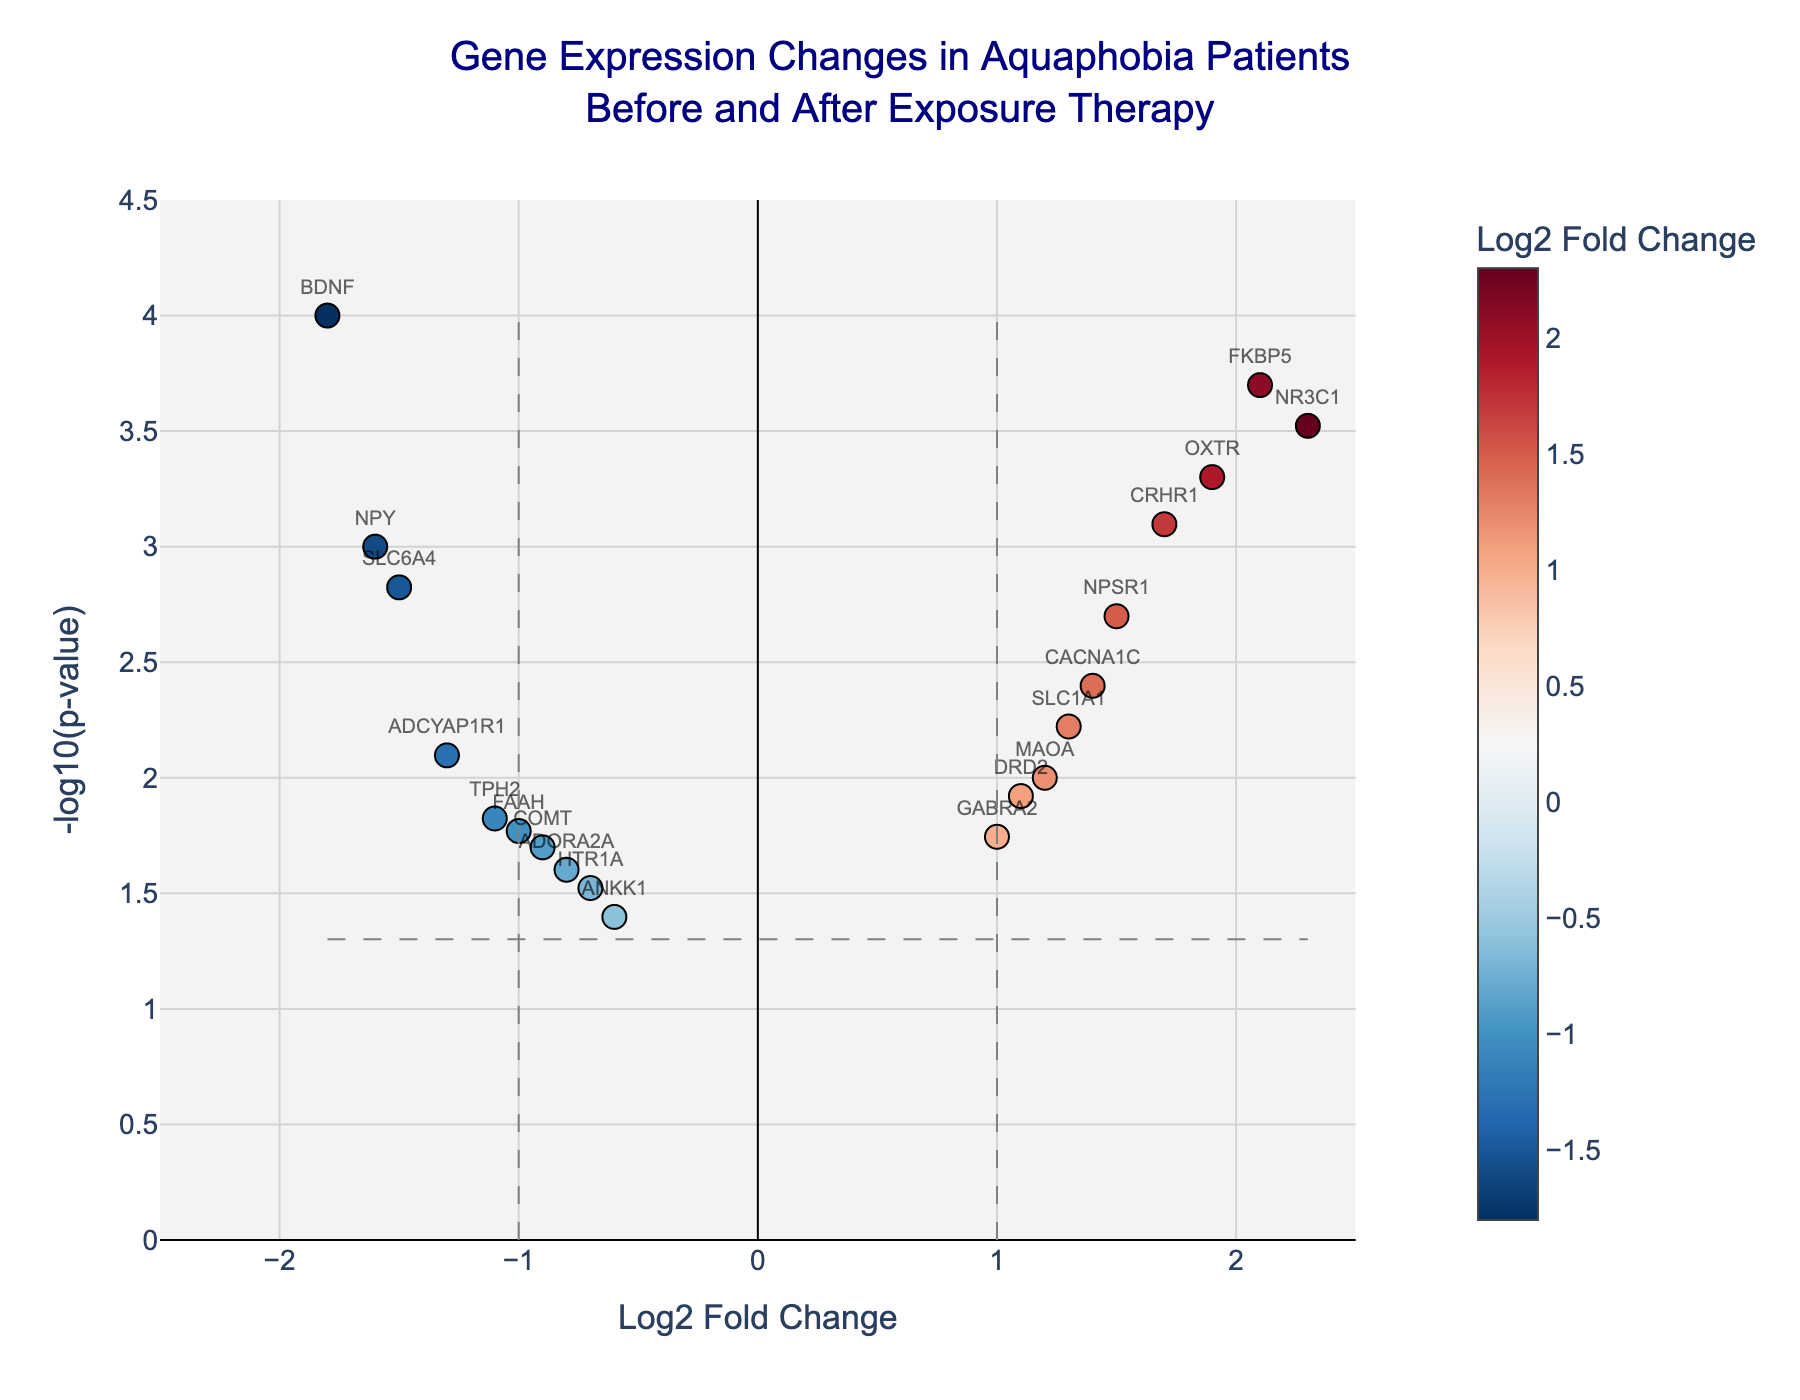What is the title of the figure? The title is usually located at the top of the figure and is used to summarize the content of the plot. The title in this plot is clearly displayed at the top center.
Answer: Gene Expression Changes in Aquaphobia Patients Before and After Exposure Therapy How many genes have a p-value less than 0.05? To determine this, you need to look at the horizontal line that marks the significance threshold of -log10(0.05). Any points above this line have a p-value less than 0.05. By counting these points, we find there are 15 points above the line.
Answer: 15 Which gene has the highest negative Log2 Fold Change? You need to look for the point located furthest to the left on the x-axis, which represents the most negative Log2 Fold Change. In this case, BDNF with a Log2 Fold Change of -1.8 is the furthest left.
Answer: BDNF Which gene shows the most significant change in expression? The most significant change in expression corresponds to the smallest p-value, which will have the highest -log10(p-value) in the plot. By scanning the plot, FKBP5 stands out as the gene with the highest -log10(p-value).
Answer: FKBP5 How many genes have a Log2 Fold Change greater than 1.0? To answer this, look to the right of the vertical line at Log2 Fold Change = 1.0 and count the points. The genes satisfying this condition are NR3C1, OXTR, FKBP5, CRHR1, NPSR1, CACNA1C, SLC1A1, and DRD2.
Answer: 8 Which gene with a Log2 Fold Change greater than 1.0 has a p-value closest to 0.001? First, identify genes with Log2 Fold Change greater than 1.0 (NR3C1, OXTR, FKBP5, CRHR1, NPSR1, CACNA1C, SLC1A1, DRD2). Then, check their p-values to see which one is closest to 0.001. NPSR1 has a p-value of 0.0020, which is closest to 0.001.
Answer: NPSR1 Compare the Log2 Fold Change of the genes with the highest and lowest p-values. The gene with the highest p-value (most insignificant) is ANKK1 with a p-value of 0.0400 and Log2 Fold Change of -0.6. The gene with the lowest p-value (most significant) is BDNF with a p-value of 0.0001 and Log2 Fold Change of -1.8. Comparing their Log2 Fold Changes, ANKK1 is less negative than BDNF.
Answer: ANKK1 has a Log2 Fold Change of -0.6, whereas BDNF has -1.8 Which gene has a Log2 Fold Change close to zero but still passes the significance threshold of p < 0.05? To find this, look for genes close to the center line (Log2 Fold Change = 0) and above the horizontal significance threshold line. GABRA2 has a Log2 Fold Change of 1.0 and a p-value of 0.0180, making it fit the criteria.
Answer: GABRA2 